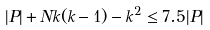Convert formula to latex. <formula><loc_0><loc_0><loc_500><loc_500>| P | + N k ( k - 1 ) - k ^ { 2 } \leq 7 . 5 | P |</formula> 